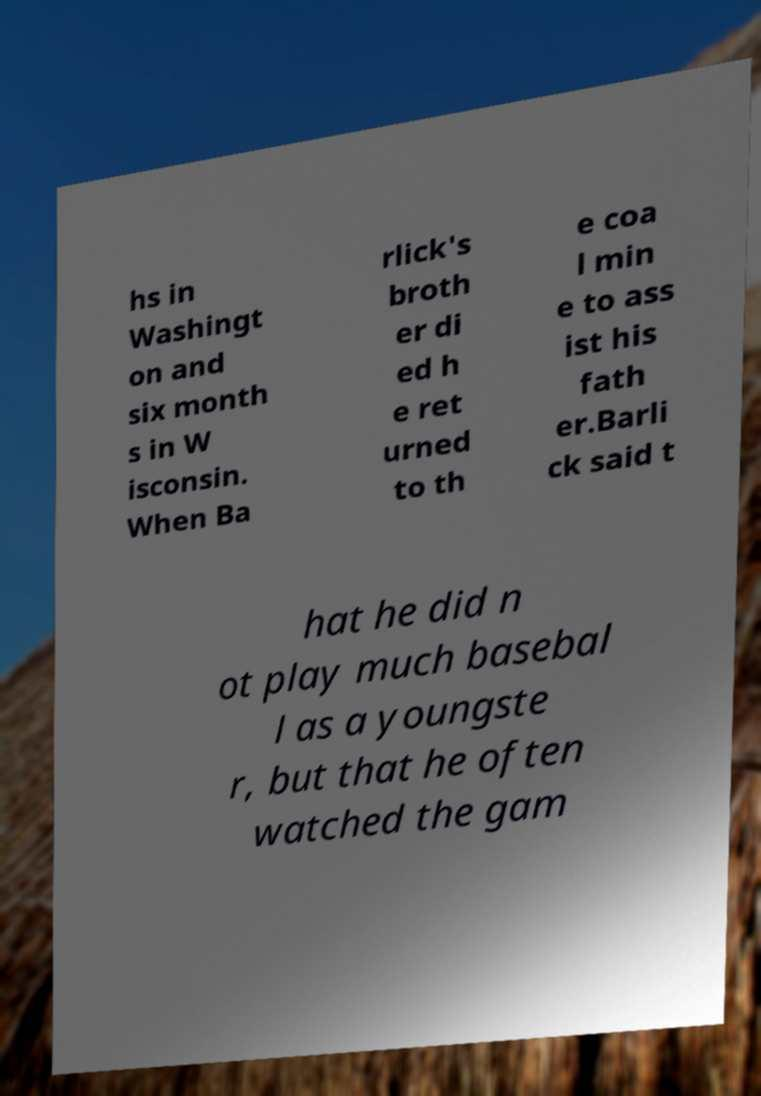Can you read and provide the text displayed in the image?This photo seems to have some interesting text. Can you extract and type it out for me? hs in Washingt on and six month s in W isconsin. When Ba rlick's broth er di ed h e ret urned to th e coa l min e to ass ist his fath er.Barli ck said t hat he did n ot play much basebal l as a youngste r, but that he often watched the gam 